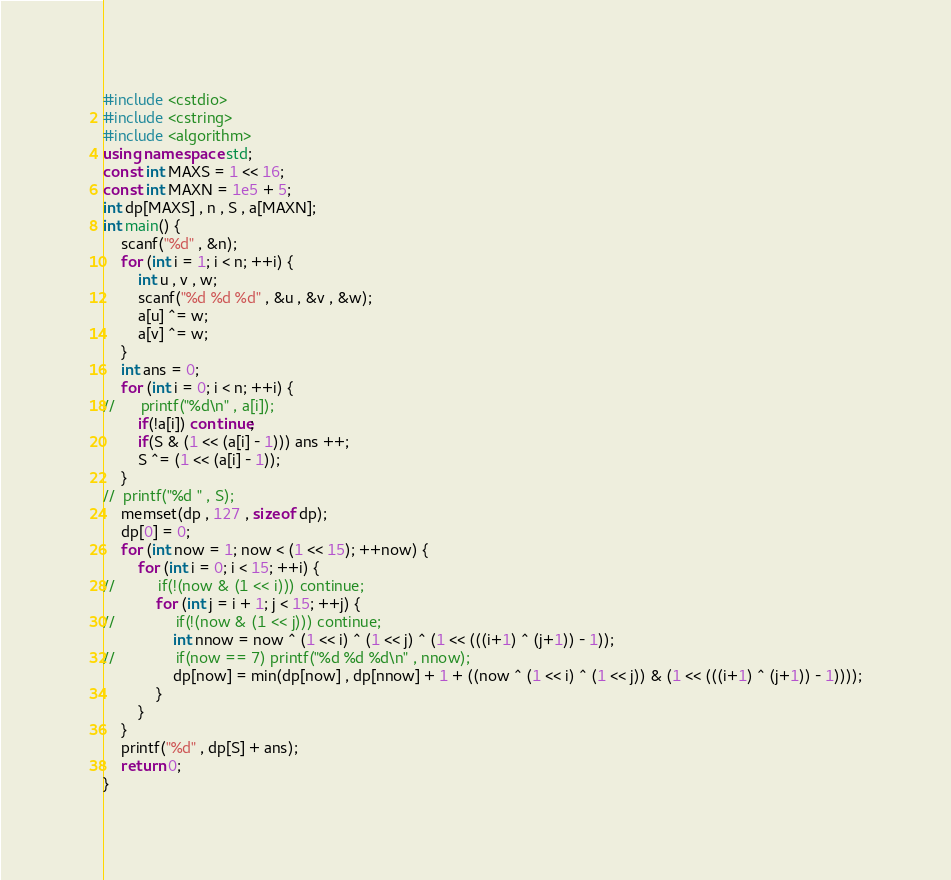Convert code to text. <code><loc_0><loc_0><loc_500><loc_500><_C++_>#include <cstdio>
#include <cstring>
#include <algorithm>
using namespace std;
const int MAXS = 1 << 16;
const int MAXN = 1e5 + 5;
int dp[MAXS] , n , S , a[MAXN];
int main() {
	scanf("%d" , &n);
	for (int i = 1; i < n; ++i) {
		int u , v , w;
		scanf("%d %d %d" , &u , &v , &w);
		a[u] ^= w;
		a[v] ^= w;
	}
	int ans = 0;
	for (int i = 0; i < n; ++i) {
//		printf("%d\n" , a[i]);
		if(!a[i]) continue;
		if(S & (1 << (a[i] - 1))) ans ++;
		S ^= (1 << (a[i] - 1));
	} 
//	printf("%d " , S);
	memset(dp , 127 , sizeof dp);
	dp[0] = 0;
	for (int now = 1; now < (1 << 15); ++now) {
		for (int i = 0; i < 15; ++i) {
//			if(!(now & (1 << i))) continue;
			for (int j = i + 1; j < 15; ++j) {
//				if(!(now & (1 << j))) continue;
				int nnow = now ^ (1 << i) ^ (1 << j) ^ (1 << (((i+1) ^ (j+1)) - 1));
//				if(now == 7) printf("%d %d %d\n" , nnow);
				dp[now] = min(dp[now] , dp[nnow] + 1 + ((now ^ (1 << i) ^ (1 << j)) & (1 << (((i+1) ^ (j+1)) - 1))));
			}
		}
	}
	printf("%d" , dp[S] + ans);
	return 0;
}</code> 